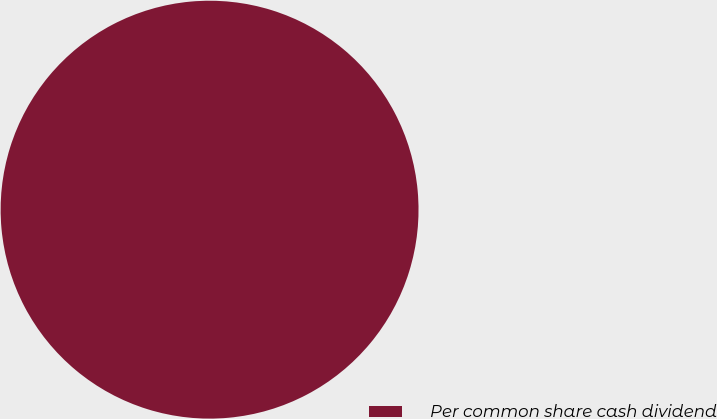Convert chart to OTSL. <chart><loc_0><loc_0><loc_500><loc_500><pie_chart><fcel>Per common share cash dividend<nl><fcel>100.0%<nl></chart> 